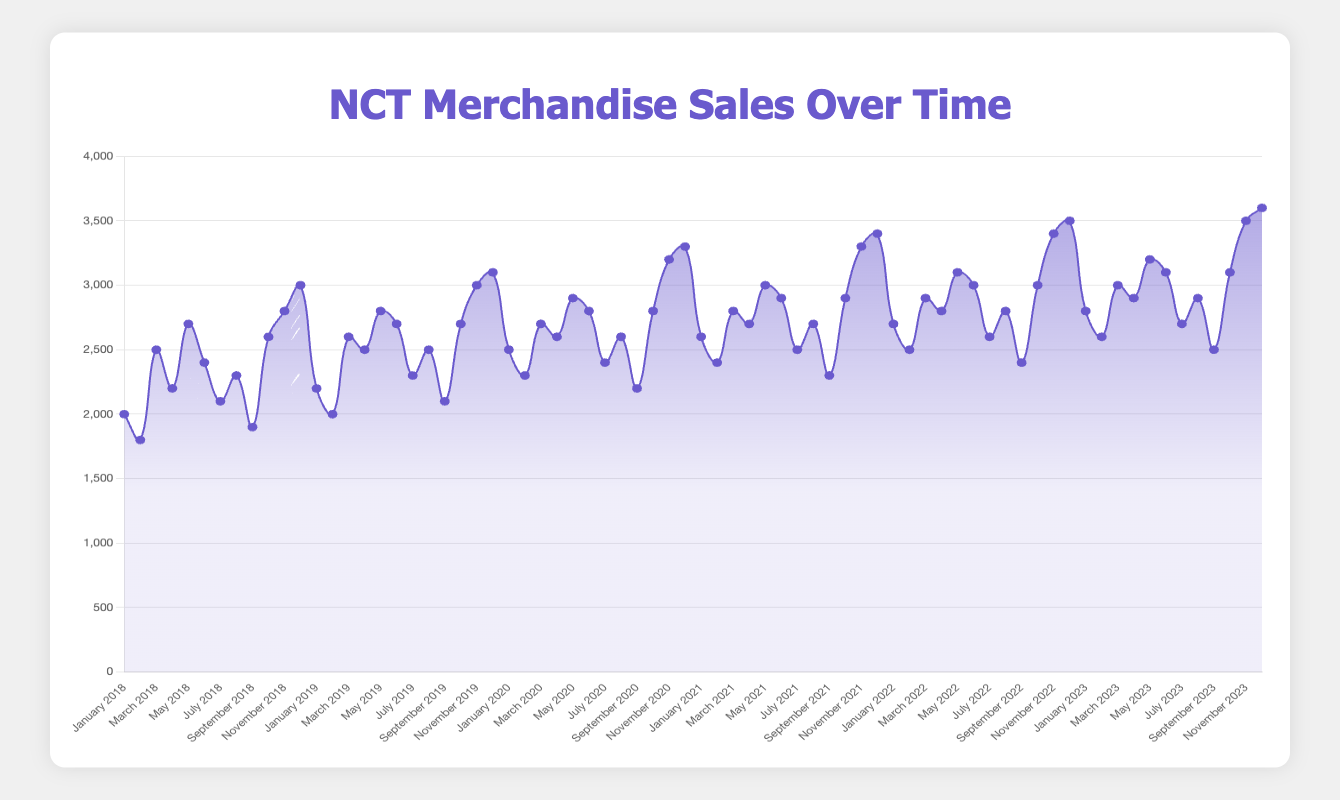What is the highest sales value recorded in any month? The figure shows monthly sales values over 5 years. Identify the peak value by visually scanning through the entire plot. The highest point on the y-axis corresponds to the highest sales value.
Answer: 3600 Which month and year saw the lowest sales? By visually inspecting the plot, look for the lowest point on the line chart. This point marks the month and year with the lowest sales value. Refer to the x-axis for the month and year.
Answer: September 2018 How do sales in November 2018 compare to sales in December 2018? Locate the points corresponding to November 2018 and December 2018 on the x-axis. Compare their y-axis values to see which is higher or if they are equal.
Answer: December 2018 is higher Which year had the highest average monthly sales? Calculate the average monthly sales for each year by summing the monthly sales and dividing by 12. Compare averages across years.
Answer: 2023 